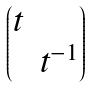<formula> <loc_0><loc_0><loc_500><loc_500>\begin{pmatrix} t & \\ & t ^ { - 1 } \end{pmatrix}</formula> 